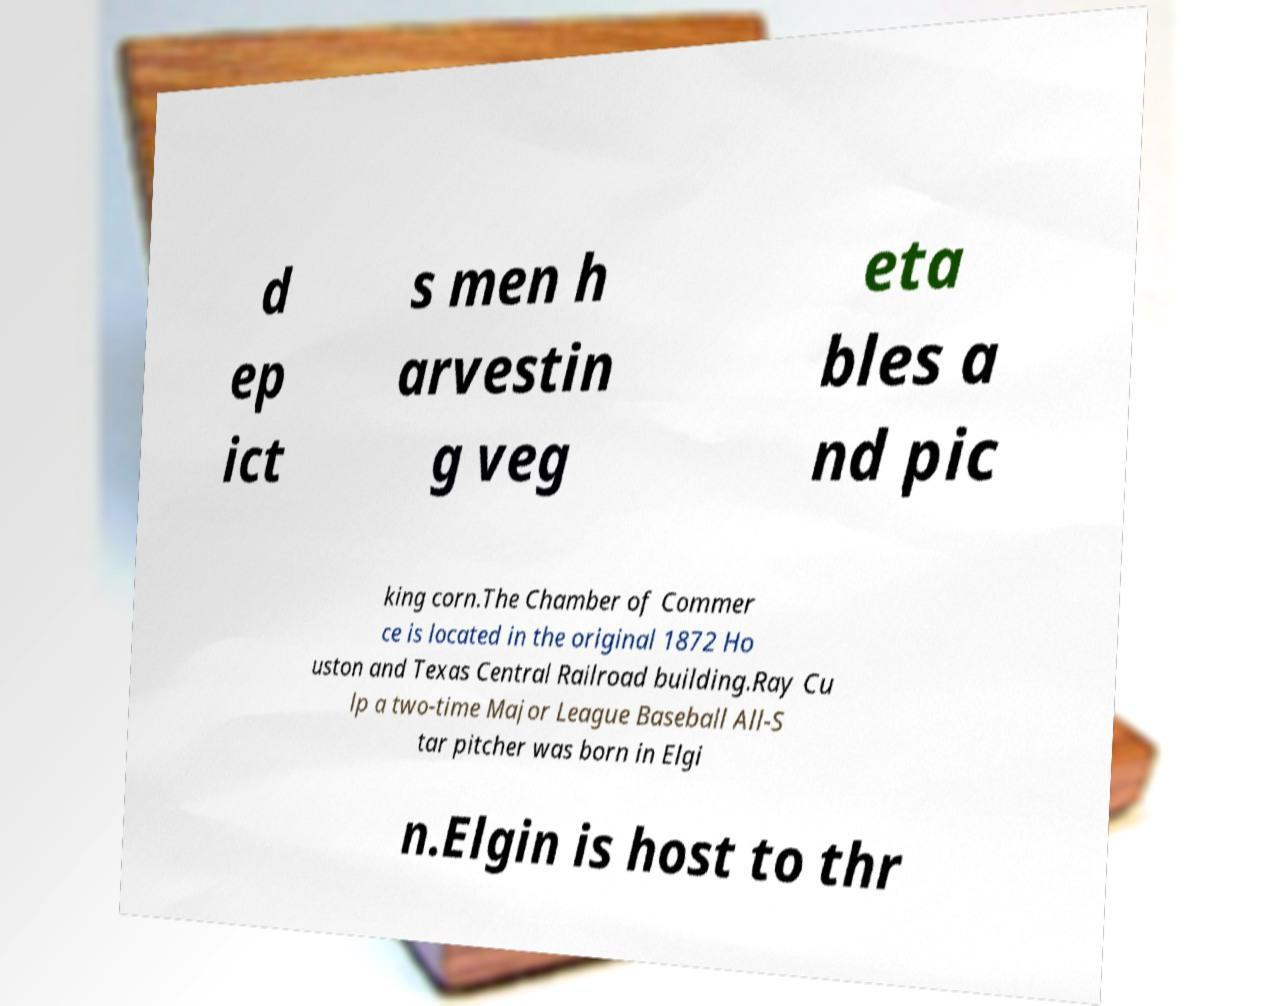Please identify and transcribe the text found in this image. d ep ict s men h arvestin g veg eta bles a nd pic king corn.The Chamber of Commer ce is located in the original 1872 Ho uston and Texas Central Railroad building.Ray Cu lp a two-time Major League Baseball All-S tar pitcher was born in Elgi n.Elgin is host to thr 